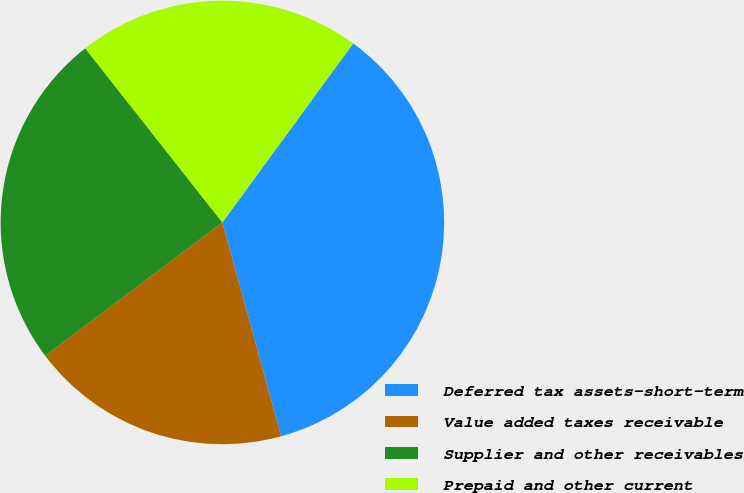<chart> <loc_0><loc_0><loc_500><loc_500><pie_chart><fcel>Deferred tax assets-short-term<fcel>Value added taxes receivable<fcel>Supplier and other receivables<fcel>Prepaid and other current<nl><fcel>35.69%<fcel>19.0%<fcel>24.65%<fcel>20.66%<nl></chart> 